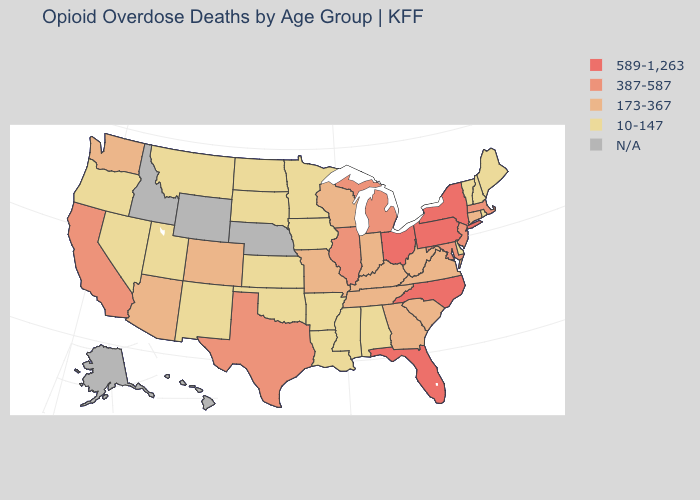What is the lowest value in the USA?
Write a very short answer. 10-147. Name the states that have a value in the range 10-147?
Write a very short answer. Alabama, Arkansas, Delaware, Iowa, Kansas, Louisiana, Maine, Minnesota, Mississippi, Montana, Nevada, New Hampshire, New Mexico, North Dakota, Oklahoma, Oregon, Rhode Island, South Dakota, Utah, Vermont. What is the highest value in states that border Wyoming?
Give a very brief answer. 173-367. Does the map have missing data?
Concise answer only. Yes. What is the value of Vermont?
Be succinct. 10-147. Which states have the highest value in the USA?
Be succinct. Florida, New York, North Carolina, Ohio, Pennsylvania. Name the states that have a value in the range 10-147?
Quick response, please. Alabama, Arkansas, Delaware, Iowa, Kansas, Louisiana, Maine, Minnesota, Mississippi, Montana, Nevada, New Hampshire, New Mexico, North Dakota, Oklahoma, Oregon, Rhode Island, South Dakota, Utah, Vermont. What is the value of Colorado?
Short answer required. 173-367. Does the first symbol in the legend represent the smallest category?
Keep it brief. No. Which states have the lowest value in the USA?
Concise answer only. Alabama, Arkansas, Delaware, Iowa, Kansas, Louisiana, Maine, Minnesota, Mississippi, Montana, Nevada, New Hampshire, New Mexico, North Dakota, Oklahoma, Oregon, Rhode Island, South Dakota, Utah, Vermont. Name the states that have a value in the range 173-367?
Keep it brief. Arizona, Colorado, Connecticut, Georgia, Indiana, Kentucky, Missouri, South Carolina, Tennessee, Virginia, Washington, West Virginia, Wisconsin. What is the value of Oregon?
Short answer required. 10-147. How many symbols are there in the legend?
Concise answer only. 5. What is the highest value in states that border Iowa?
Be succinct. 387-587. 